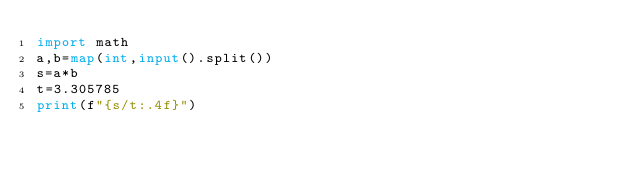Convert code to text. <code><loc_0><loc_0><loc_500><loc_500><_Python_>import math
a,b=map(int,input().split())
s=a*b
t=3.305785
print(f"{s/t:.4f}")
</code> 